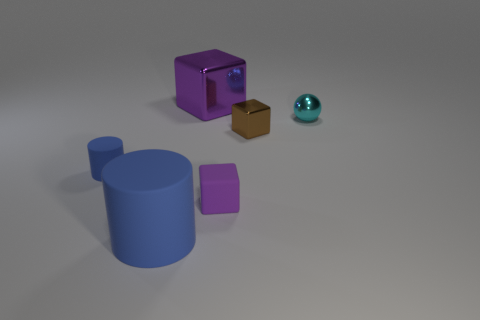Add 2 small blue things. How many objects exist? 8 Subtract all cylinders. How many objects are left? 4 Add 5 brown cubes. How many brown cubes are left? 6 Add 5 brown matte things. How many brown matte things exist? 5 Subtract 2 purple cubes. How many objects are left? 4 Subtract all matte objects. Subtract all cyan shiny things. How many objects are left? 2 